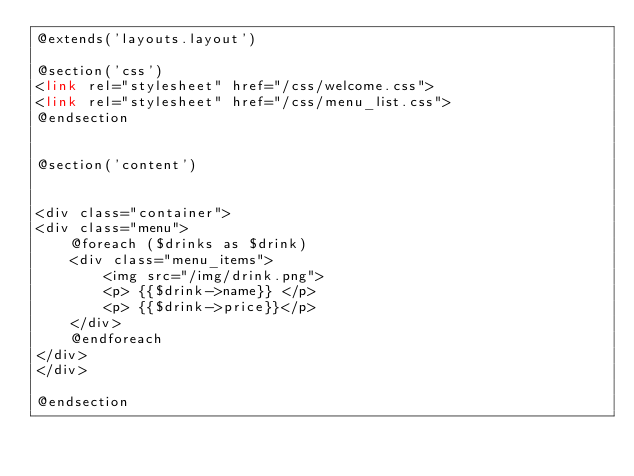<code> <loc_0><loc_0><loc_500><loc_500><_PHP_>@extends('layouts.layout')

@section('css')
<link rel="stylesheet" href="/css/welcome.css">
<link rel="stylesheet" href="/css/menu_list.css">
@endsection


@section('content')


<div class="container">
<div class="menu">
    @foreach ($drinks as $drink)
    <div class="menu_items">
        <img src="/img/drink.png">
        <p> {{$drink->name}} </p>
        <p> {{$drink->price}}</p>
    </div>
    @endforeach
</div>
</div>

@endsection

</code> 